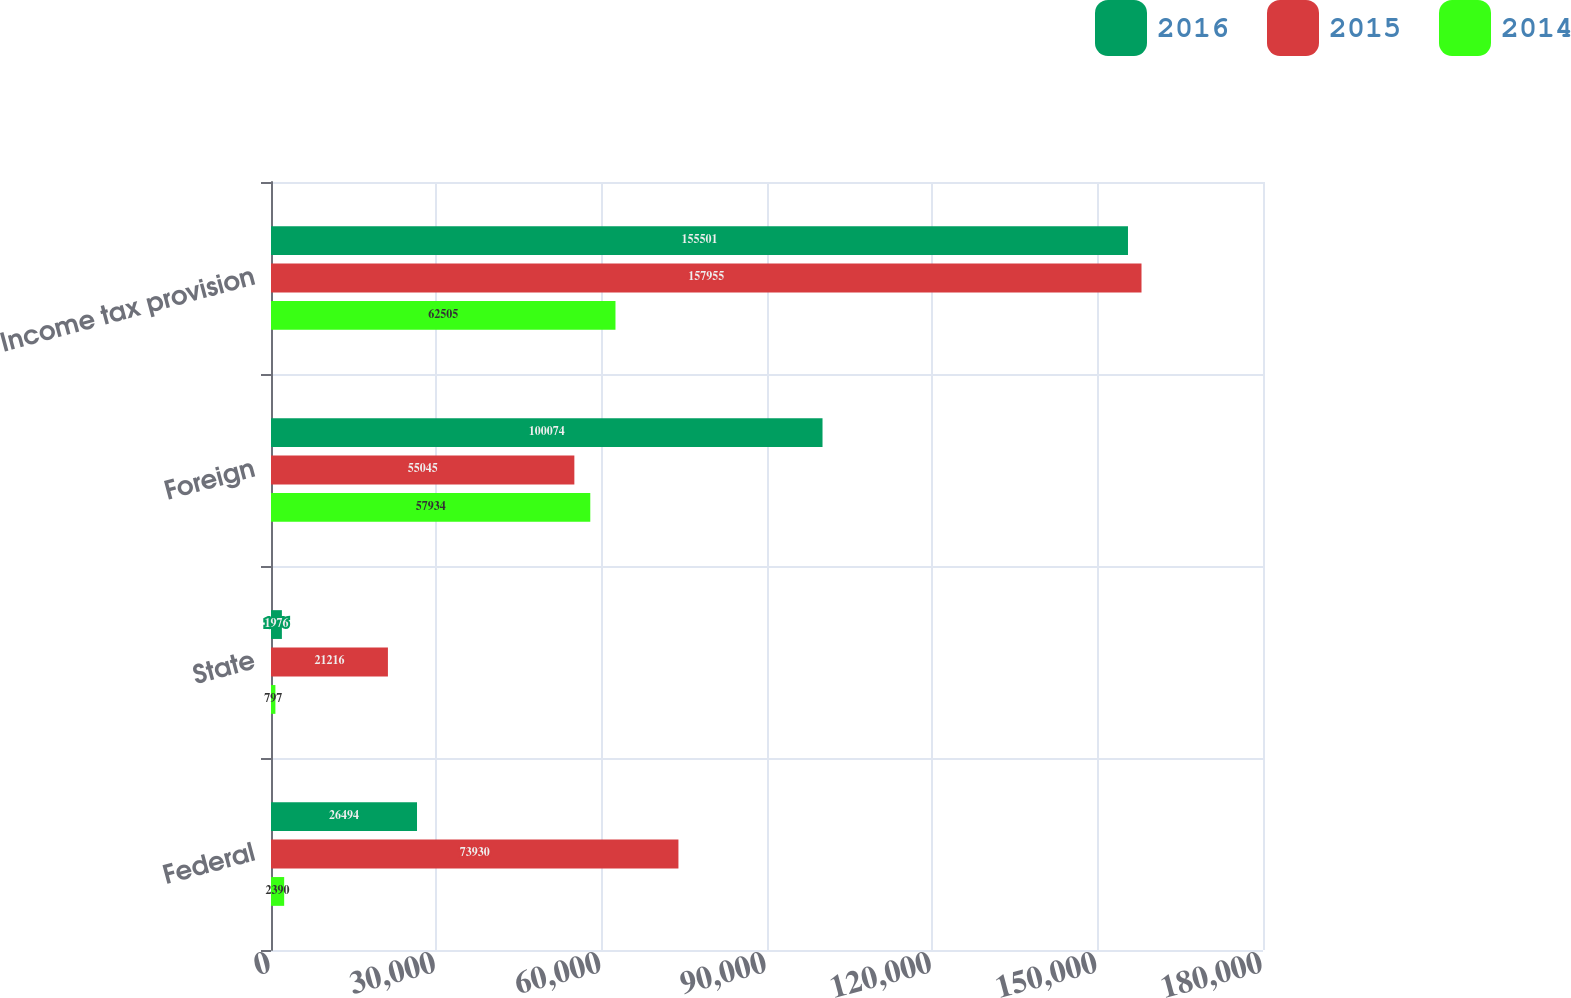<chart> <loc_0><loc_0><loc_500><loc_500><stacked_bar_chart><ecel><fcel>Federal<fcel>State<fcel>Foreign<fcel>Income tax provision<nl><fcel>2016<fcel>26494<fcel>1976<fcel>100074<fcel>155501<nl><fcel>2015<fcel>73930<fcel>21216<fcel>55045<fcel>157955<nl><fcel>2014<fcel>2390<fcel>797<fcel>57934<fcel>62505<nl></chart> 